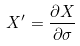Convert formula to latex. <formula><loc_0><loc_0><loc_500><loc_500>X ^ { \prime } = \frac { \partial X } { \partial \sigma }</formula> 